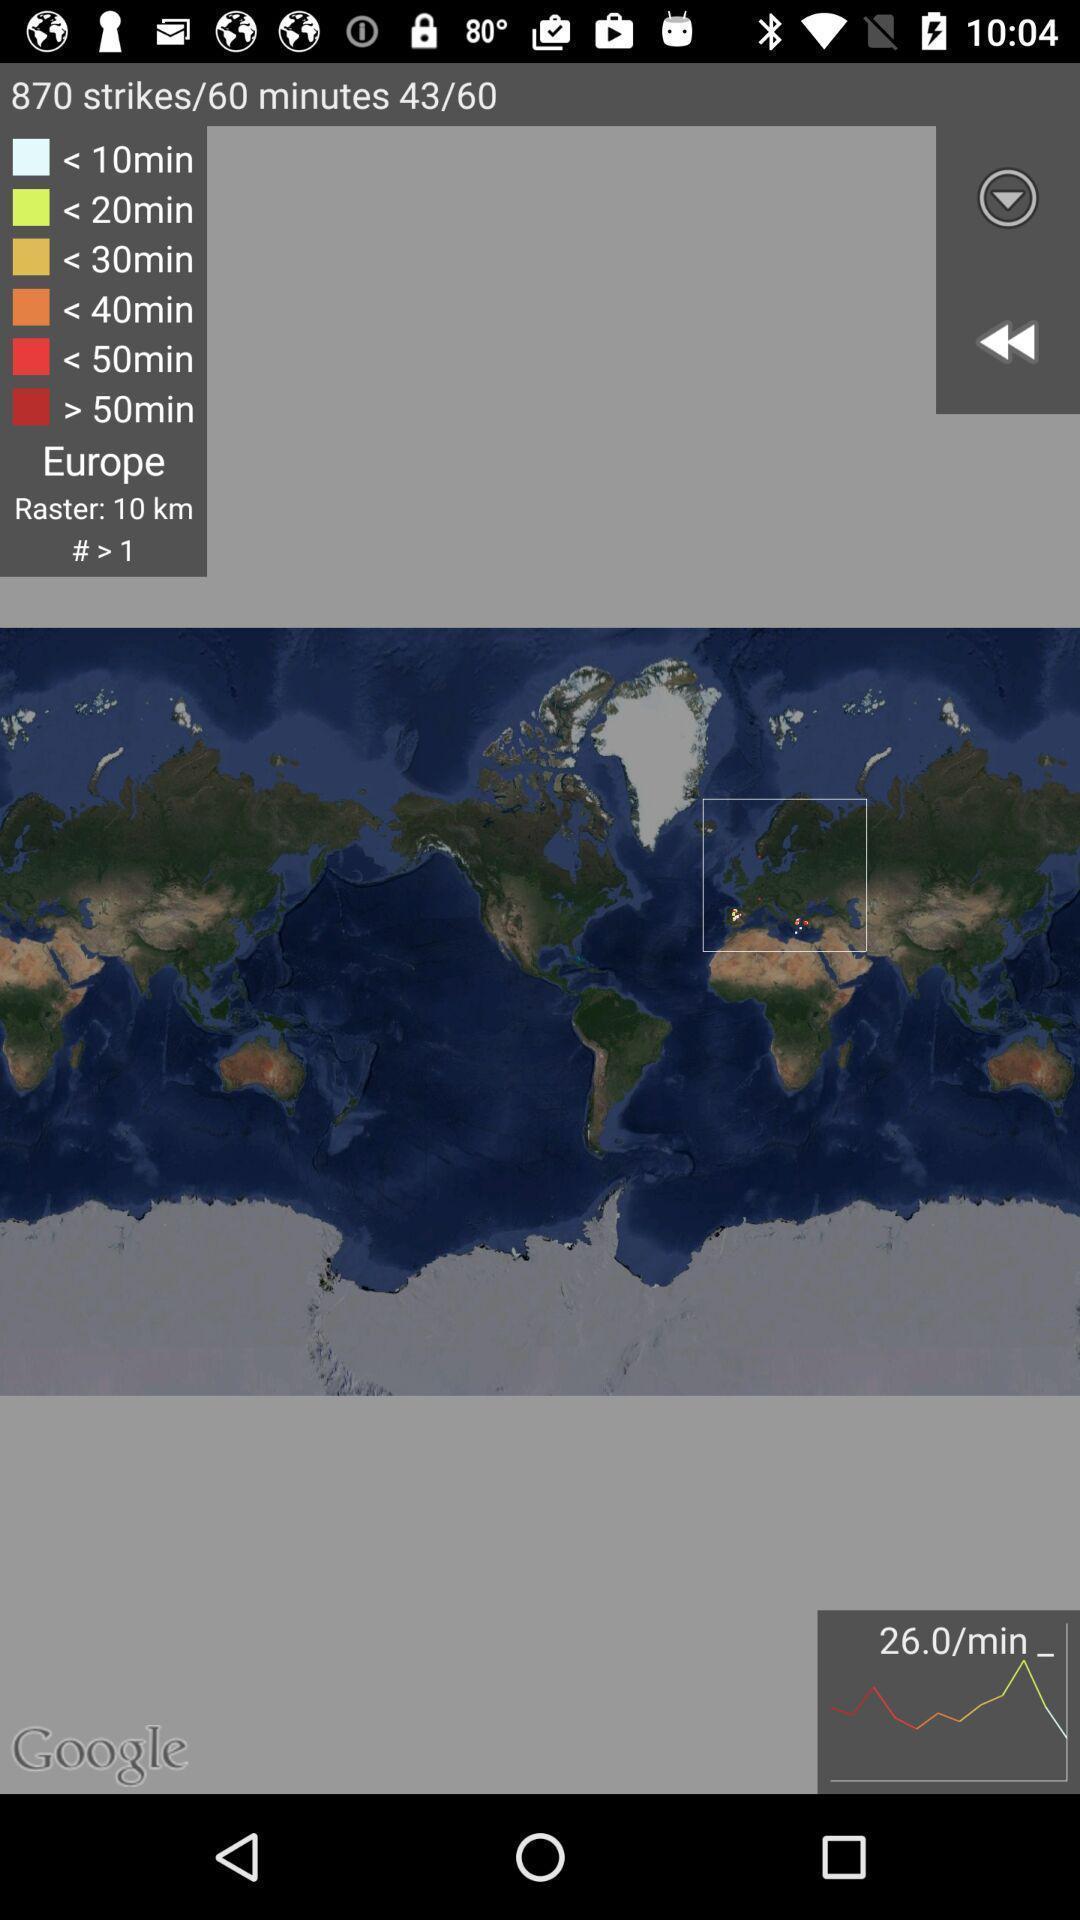Tell me about the visual elements in this screen capture. Page displaying lightning details on map. 